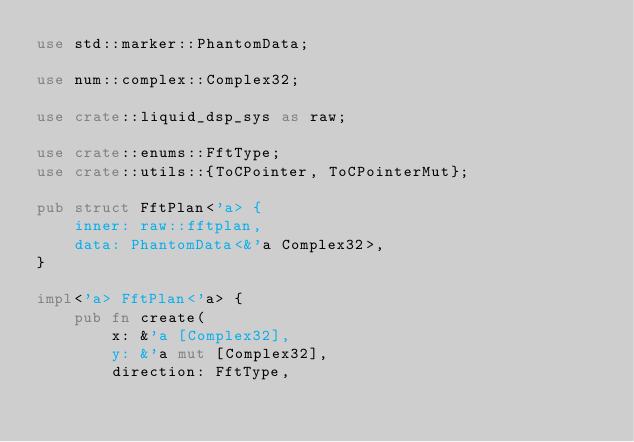Convert code to text. <code><loc_0><loc_0><loc_500><loc_500><_Rust_>use std::marker::PhantomData;

use num::complex::Complex32;

use crate::liquid_dsp_sys as raw;

use crate::enums::FftType;
use crate::utils::{ToCPointer, ToCPointerMut};

pub struct FftPlan<'a> {
    inner: raw::fftplan,
    data: PhantomData<&'a Complex32>,
}

impl<'a> FftPlan<'a> {
    pub fn create(
        x: &'a [Complex32],
        y: &'a mut [Complex32],
        direction: FftType,</code> 